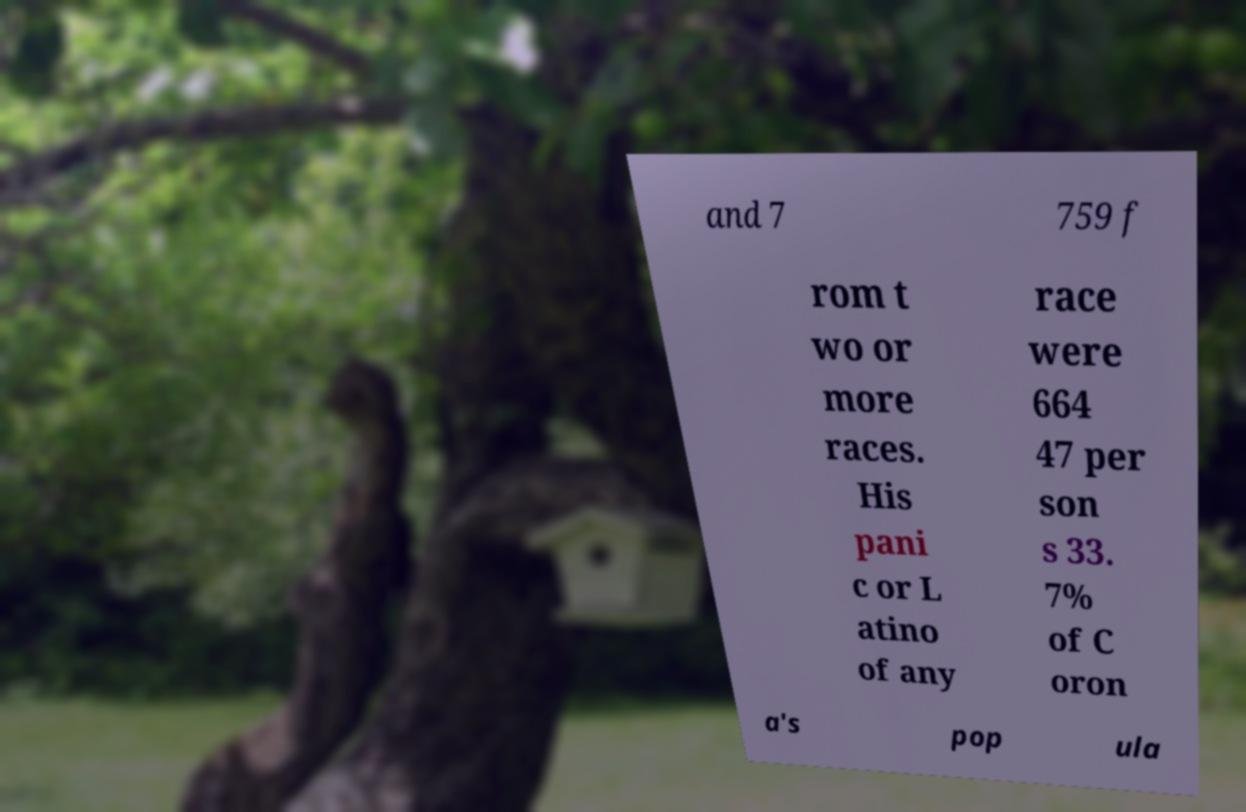There's text embedded in this image that I need extracted. Can you transcribe it verbatim? and 7 759 f rom t wo or more races. His pani c or L atino of any race were 664 47 per son s 33. 7% of C oron a's pop ula 